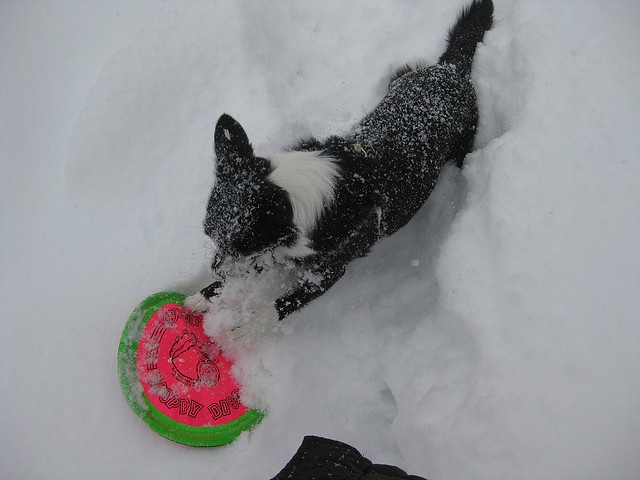Describe the objects in this image and their specific colors. I can see dog in darkgray, black, and gray tones and frisbee in darkgray, brown, and darkgreen tones in this image. 